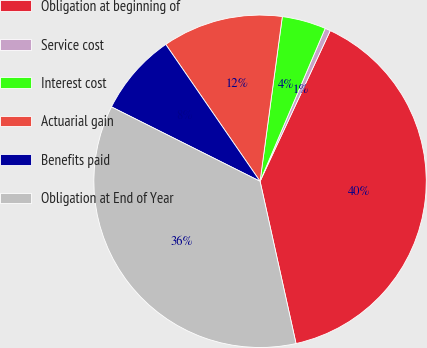Convert chart. <chart><loc_0><loc_0><loc_500><loc_500><pie_chart><fcel>Obligation at beginning of<fcel>Service cost<fcel>Interest cost<fcel>Actuarial gain<fcel>Benefits paid<fcel>Obligation at End of Year<nl><fcel>39.59%<fcel>0.53%<fcel>4.27%<fcel>11.74%<fcel>8.01%<fcel>35.86%<nl></chart> 